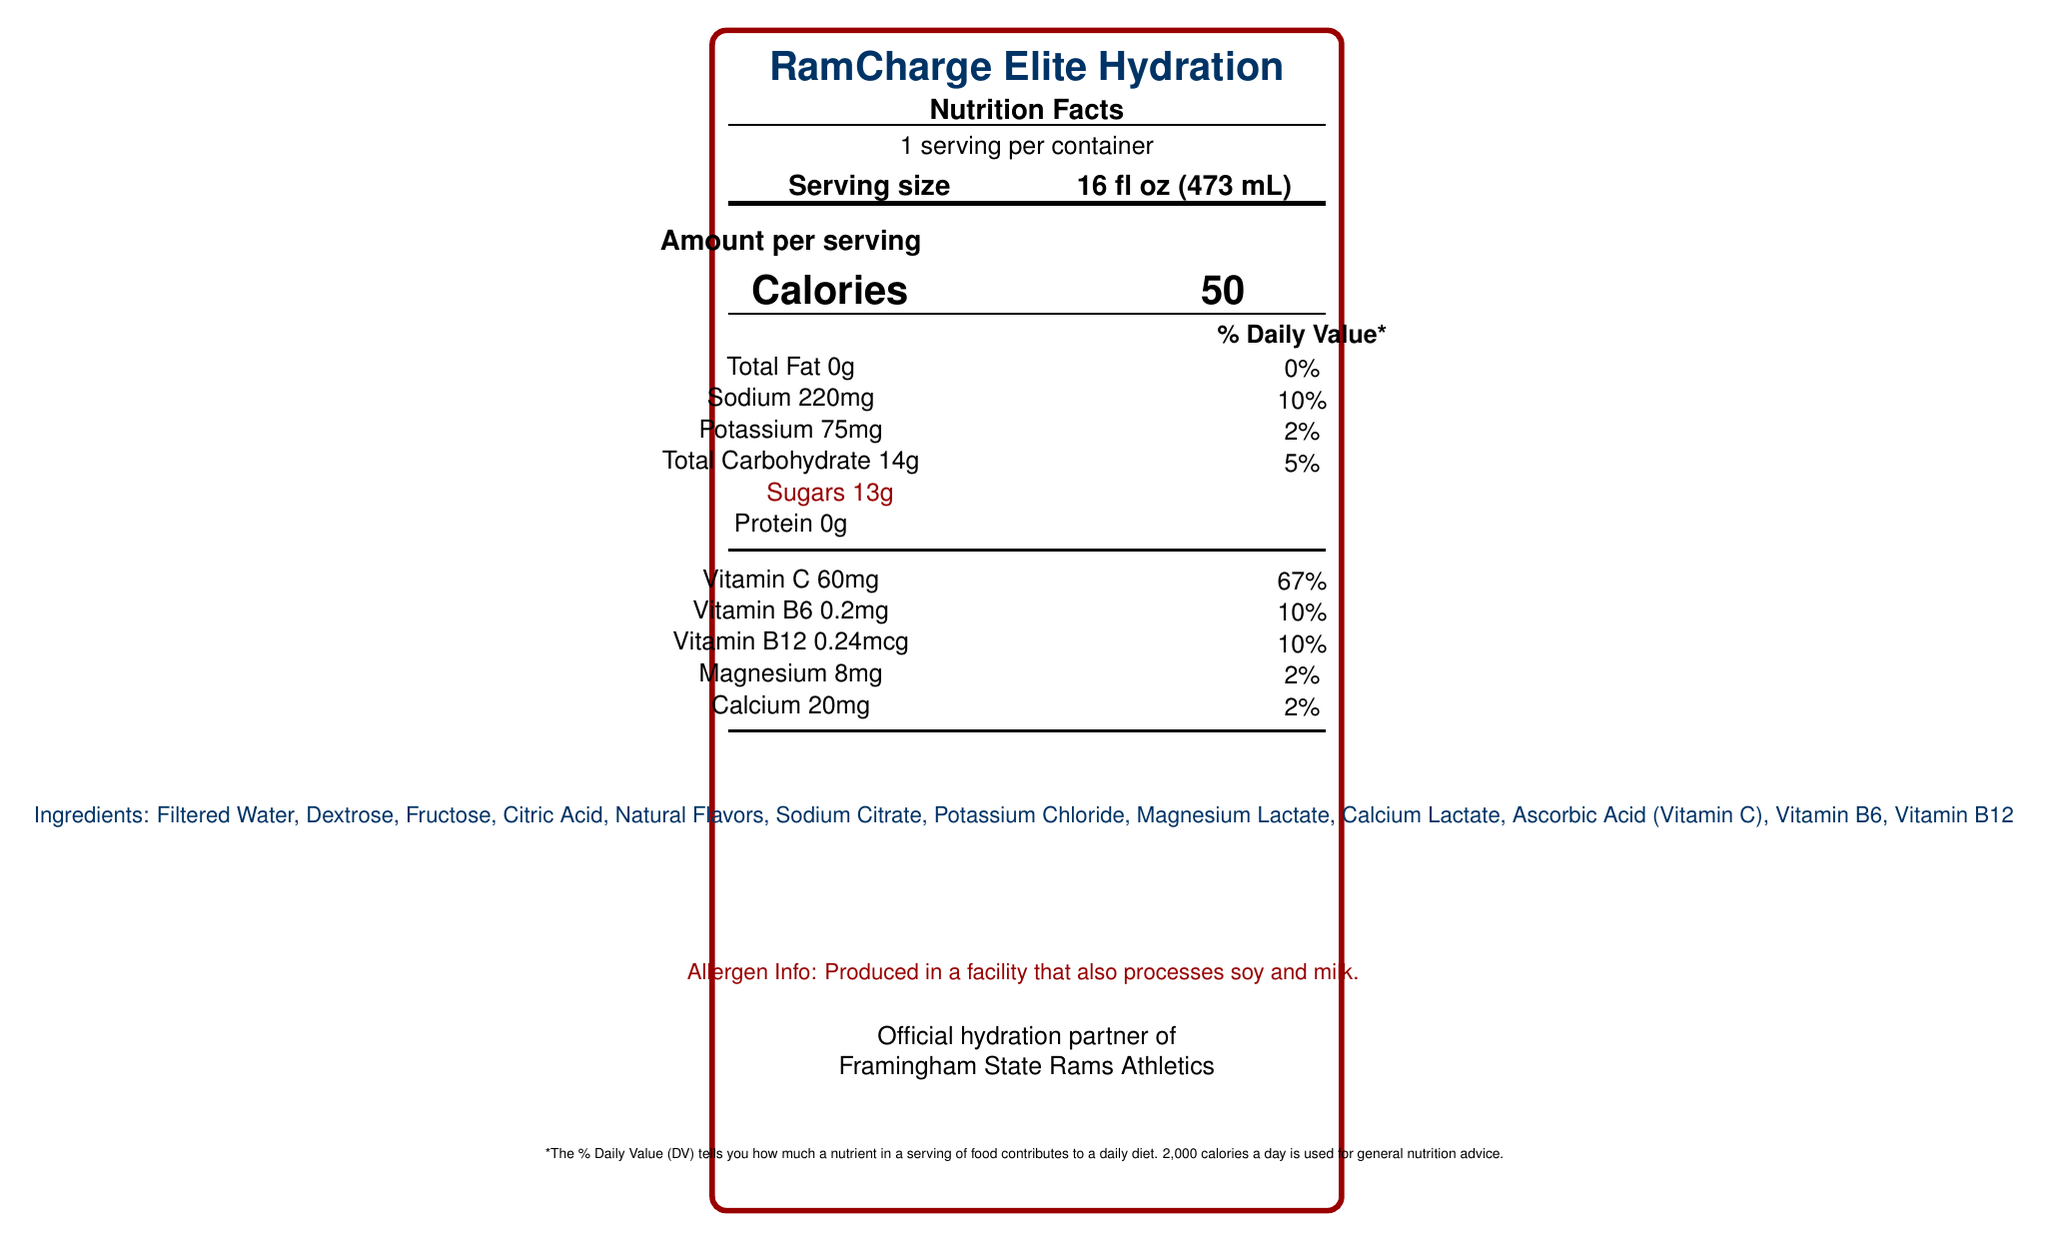what is the serving size? The serving size is listed as 16 fl oz (473 mL) in the document.
Answer: 16 fl oz (473 mL) how many calories are in one serving? The document clearly states that there are 50 calories per serving.
Answer: 50 how much sodium is in a serving? The amount of sodium per serving is listed as 220 mg.
Answer: 220 mg which vitamins are included and in what quantities? The nutrition facts list Vitamin C, Vitamin B6, and Vitamin B12 along with their specific quantities.
Answer: Vitamin C 60 mg, Vitamin B6 0.2 mg, Vitamin B12 0.24 mcg what is the official endorsement mentioned in the document? The document states that RamCharge Elite Hydration is the official hydration partner of Framingham State Rams Athletics.
Answer: Official hydration partner of Framingham State Rams Athletics what type of ingredients does the document list? The document provides a list of ingredients used in the product.
Answer: Filtered Water, Dextrose, Fructose, Citric Acid, Natural Flavors, Sodium Citrate, Potassium Chloride, Magnesium Lactate, Calcium Lactate, Ascorbic Acid (Vitamin C), Vitamin B6, Vitamin B12 how should the beverage be stored after opening? The document advises refrigerating the beverage and consuming it within 3 days of opening.
Answer: Refrigerate after opening. Consume within 3 days of opening. during what activities is this drink recommended? Usage instructions recommend consuming the drink before, during, and after training sessions or games for best results.
Answer: Before, during, and after intense training sessions or games identify one key benefit of the product. One of the key benefits listed is rapid electrolyte replenishment.
Answer: Rapid electrolyte replenishment which organization certified this product? The document mentions that the product is NSF Certified for Sport®.
Answer: NSF how many grams of total carbohydrate does one serving contain? The total carbohydrate content per serving is specified as 14 grams.
Answer: 14 g how should the product ideally be consumed according to the usage instructions? The document suggests that the product should be consumed chilled for best results.
Answer: Chilled does this product contain any protein? The nutrition facts indicate that there is 0 grams of protein in the product.
Answer: No what percentage of the daily value of magnesium does one serving provide? The document lists that one serving provides 2% of the daily value of magnesium.
Answer: 2% does the document mention any allergens? If so, which ones? The allergen info notes that the product is produced in a facility that also processes soy and milk.
Answer: Yes, produced in a facility that processes soy and milk. who helped develop this product? The product description states it was developed with input from former Framingham State Rams players.
Answer: Former Framingham State Rams players describe the product in a few sentences. The product description highlights the purpose, development background, and benefits of the drink, targeting college football players and their unique needs.
Answer: RamCharge Elite Hydration is specially formulated for the high-intensity demands of college football. Developed with input from former Framingham State Rams players, this electrolyte-rich formula helps maintain peak performance during grueling practices and game days. when is the best time to drink RamCharge Elite Hydration? The document specifies that it should be consumed before, during, and after training sessions or games, but does not specify an exact "best time."
Answer: Cannot be determined what is the total amount of sugar per serving? A. 0g B. 13g C. 5g D. 20g The nutrition facts label states that there are 13 grams of sugar per serving.
Answer: B. 13g what is the purpose of the product according to the description? A. To provide a meal replacement B. To support muscle growth C. To replenish electrolytes during intense activity The key benefits and product description both emphasize electrolyte replenishment during intense activities.
Answer: C. To replenish electrolytes during intense activity is this product high in calories? The document specifies that each serving contains only 50 calories, which is relatively low.
Answer: No 